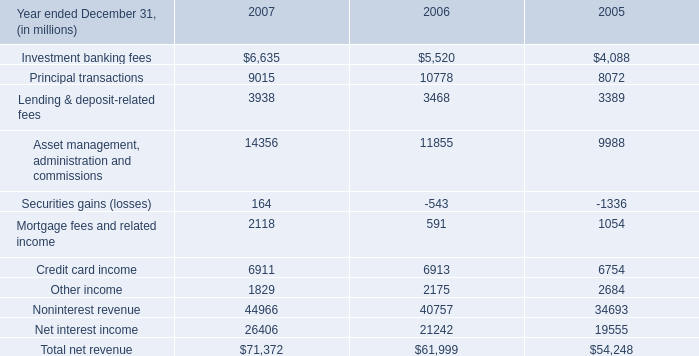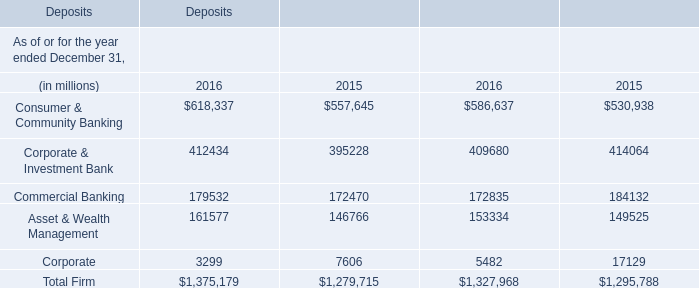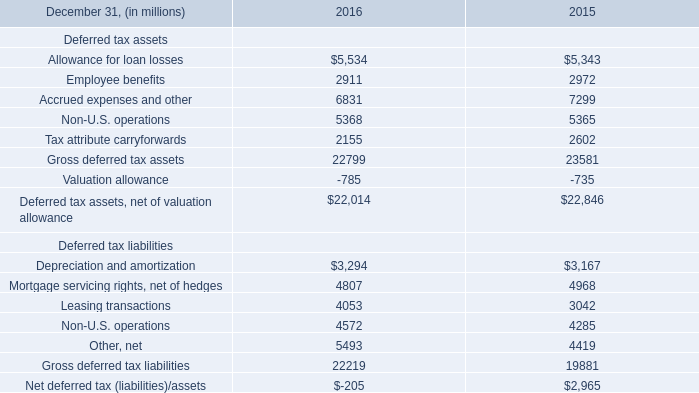what's the total amount of Net interest income of 2006, Depreciation and amortization Deferred tax liabilities of 2016, and Allowance for loan losses of 2015 ? 
Computations: ((21242.0 + 3294.0) + 5343.0)
Answer: 29879.0. 